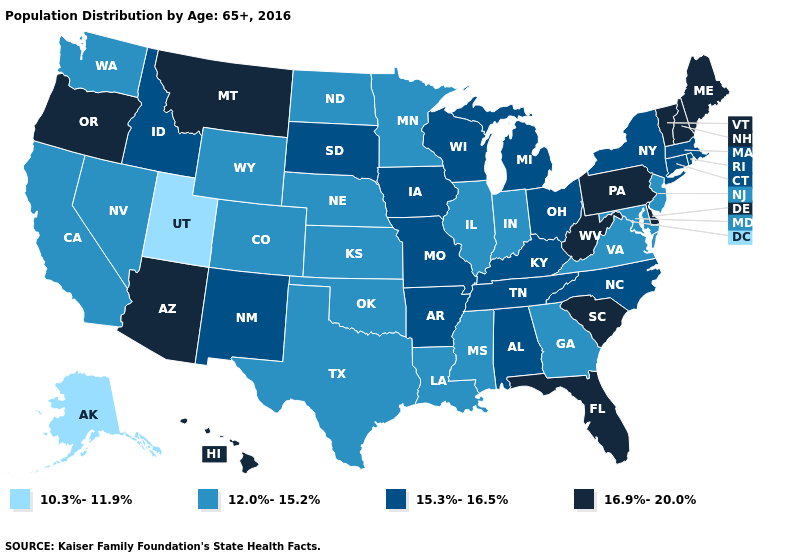Is the legend a continuous bar?
Concise answer only. No. What is the value of Colorado?
Be succinct. 12.0%-15.2%. What is the lowest value in states that border South Dakota?
Write a very short answer. 12.0%-15.2%. Does Vermont have the lowest value in the Northeast?
Be succinct. No. Among the states that border Arkansas , does Tennessee have the highest value?
Short answer required. Yes. Which states have the lowest value in the Northeast?
Keep it brief. New Jersey. What is the value of North Carolina?
Be succinct. 15.3%-16.5%. Name the states that have a value in the range 12.0%-15.2%?
Write a very short answer. California, Colorado, Georgia, Illinois, Indiana, Kansas, Louisiana, Maryland, Minnesota, Mississippi, Nebraska, Nevada, New Jersey, North Dakota, Oklahoma, Texas, Virginia, Washington, Wyoming. What is the lowest value in the USA?
Keep it brief. 10.3%-11.9%. What is the value of Illinois?
Keep it brief. 12.0%-15.2%. Which states have the lowest value in the South?
Give a very brief answer. Georgia, Louisiana, Maryland, Mississippi, Oklahoma, Texas, Virginia. What is the highest value in states that border Rhode Island?
Concise answer only. 15.3%-16.5%. What is the value of South Carolina?
Be succinct. 16.9%-20.0%. How many symbols are there in the legend?
Be succinct. 4. What is the value of Georgia?
Write a very short answer. 12.0%-15.2%. 